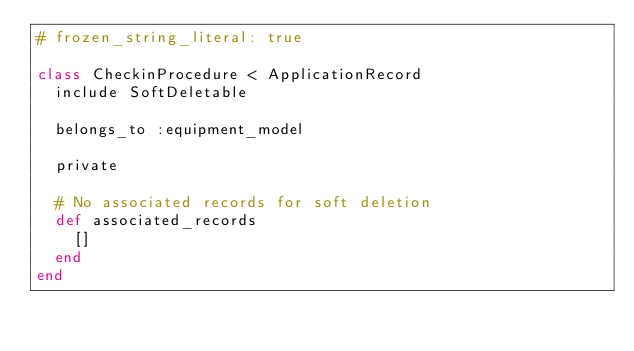Convert code to text. <code><loc_0><loc_0><loc_500><loc_500><_Ruby_># frozen_string_literal: true

class CheckinProcedure < ApplicationRecord
  include SoftDeletable

  belongs_to :equipment_model

  private

  # No associated records for soft deletion
  def associated_records
    []
  end
end
</code> 